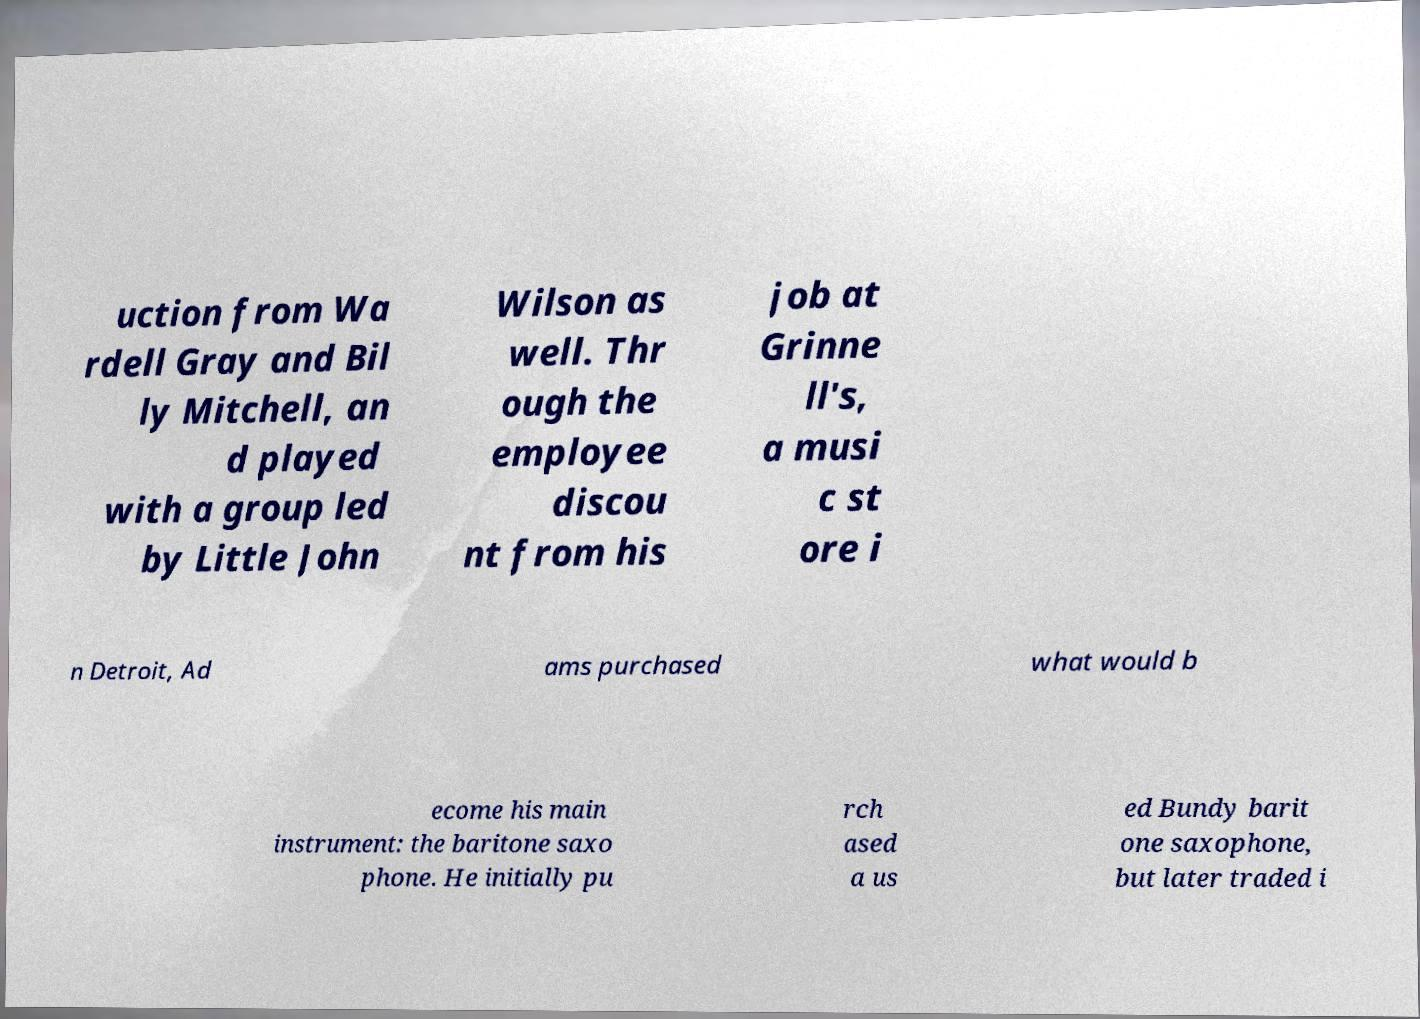Can you read and provide the text displayed in the image?This photo seems to have some interesting text. Can you extract and type it out for me? uction from Wa rdell Gray and Bil ly Mitchell, an d played with a group led by Little John Wilson as well. Thr ough the employee discou nt from his job at Grinne ll's, a musi c st ore i n Detroit, Ad ams purchased what would b ecome his main instrument: the baritone saxo phone. He initially pu rch ased a us ed Bundy barit one saxophone, but later traded i 